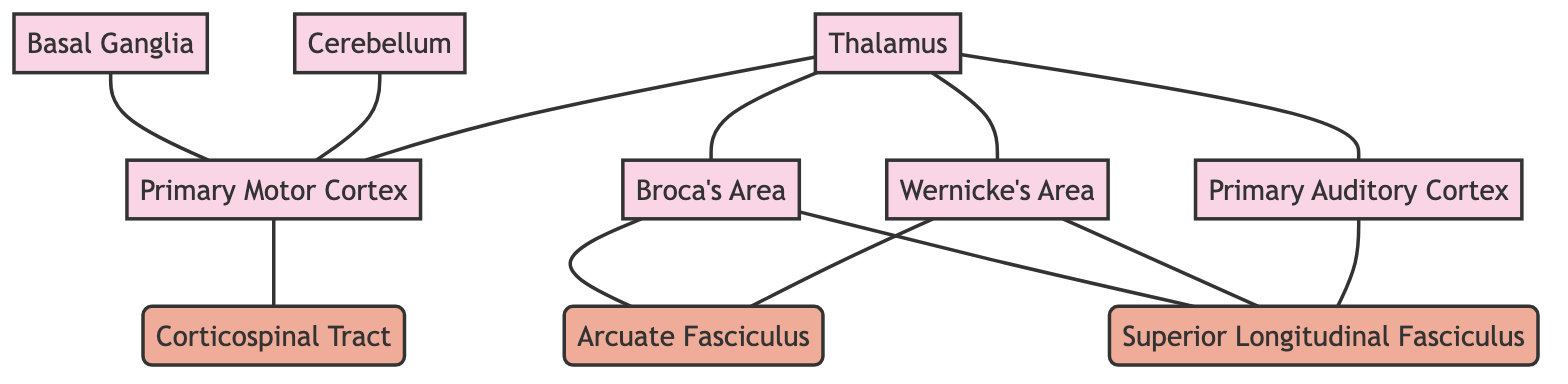What is the function of Broca's Area? Broca's Area is identified in the diagram and described as responsible for speech production and articulation.
Answer: Responsible for speech production and articulation How many brain regions are shown in the diagram? By counting the nodes labeled as brain regions in the diagram, we find there are seven: Broca's Area, Wernicke's Area, Primary Motor Cortex, Primary Auditory Cortex, Basal Ganglia, Cerebellum, and Thalamus.
Answer: 7 What connects Broca's Area and Wernicke's Area? The diagram illustrates the Arcuate Fasciculus as the connecting white matter tract between Broca's Area and Wernicke's Area.
Answer: Arcuate Fasciculus Which area is involved in the comprehension of speech? Wernicke's Area is explicitly mentioned in the diagram as the region involved in speech comprehension.
Answer: Wernicke's Area How many white matter tracts are depicted in the diagram? The diagram includes three white matter tracts: Arcuate Fasciculus, Superior Longitudinal Fasciculus, and Corticospinal Tract. Counting them yields a total of three.
Answer: 3 What role does the Basal Ganglia play in speech? According to the diagram, the Basal Ganglia is described as playing a role in motor control and speech regulation.
Answer: Motor control and speech regulation Which brain region processes auditory information? The diagram indicates that the Primary Auditory Cortex processes auditory information crucial for monitoring speech.
Answer: Primary Auditory Cortex What connects the Primary Motor Cortex to the spinal cord? The Corticospinal Tract is articulated in the diagram as carrying motor information from the Primary Motor Cortex to the spinal cord, enabling speech motor functions.
Answer: Corticospinal Tract How does the Thalamus relate to the other brain regions in the diagram? The Thalamus is detailed in the diagram as a relay station, connecting to multiple brain regions: Broca's Area, Wernicke's Area, Primary Motor Cortex, and Primary Auditory Cortex, indicating its central role in transmitting speech-related information.
Answer: Relay station for speech-related information 